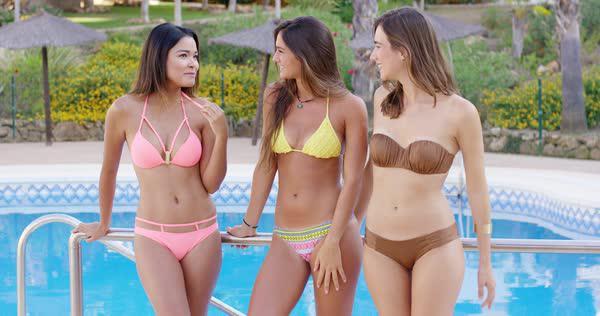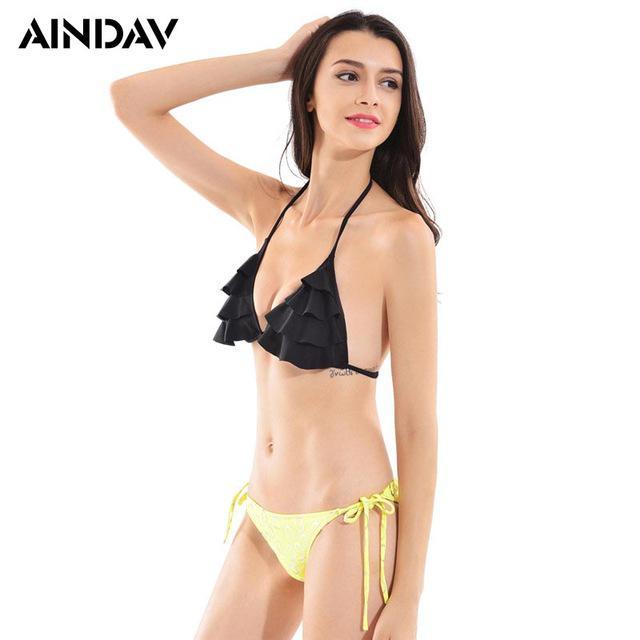The first image is the image on the left, the second image is the image on the right. For the images shown, is this caption "One woman poses in a bikini in one image, while three women pose in the other image." true? Answer yes or no. Yes. The first image is the image on the left, the second image is the image on the right. For the images shown, is this caption "One image shows a trio of bikini models with backs to the camera and arms around each other." true? Answer yes or no. No. 